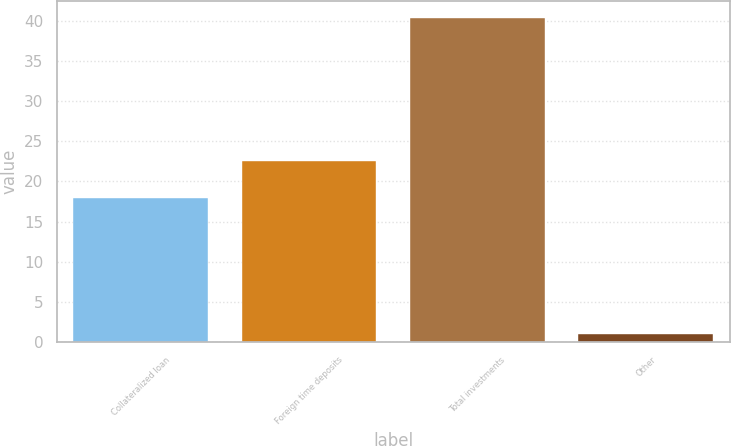Convert chart to OTSL. <chart><loc_0><loc_0><loc_500><loc_500><bar_chart><fcel>Collateralized loan<fcel>Foreign time deposits<fcel>Total investments<fcel>Other<nl><fcel>17.9<fcel>22.5<fcel>40.4<fcel>1<nl></chart> 